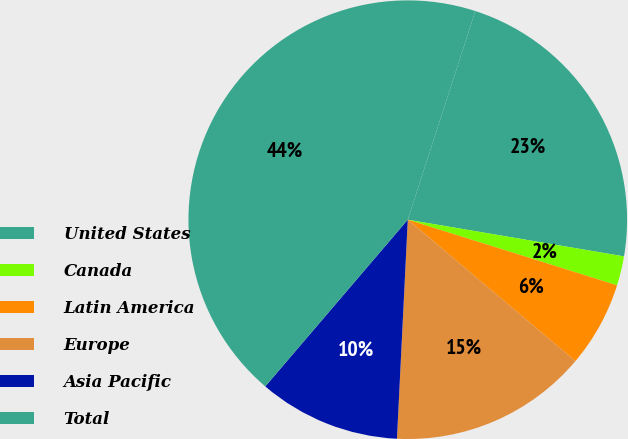Convert chart to OTSL. <chart><loc_0><loc_0><loc_500><loc_500><pie_chart><fcel>United States<fcel>Canada<fcel>Latin America<fcel>Europe<fcel>Asia Pacific<fcel>Total<nl><fcel>22.69%<fcel>2.16%<fcel>6.32%<fcel>14.63%<fcel>10.47%<fcel>43.73%<nl></chart> 